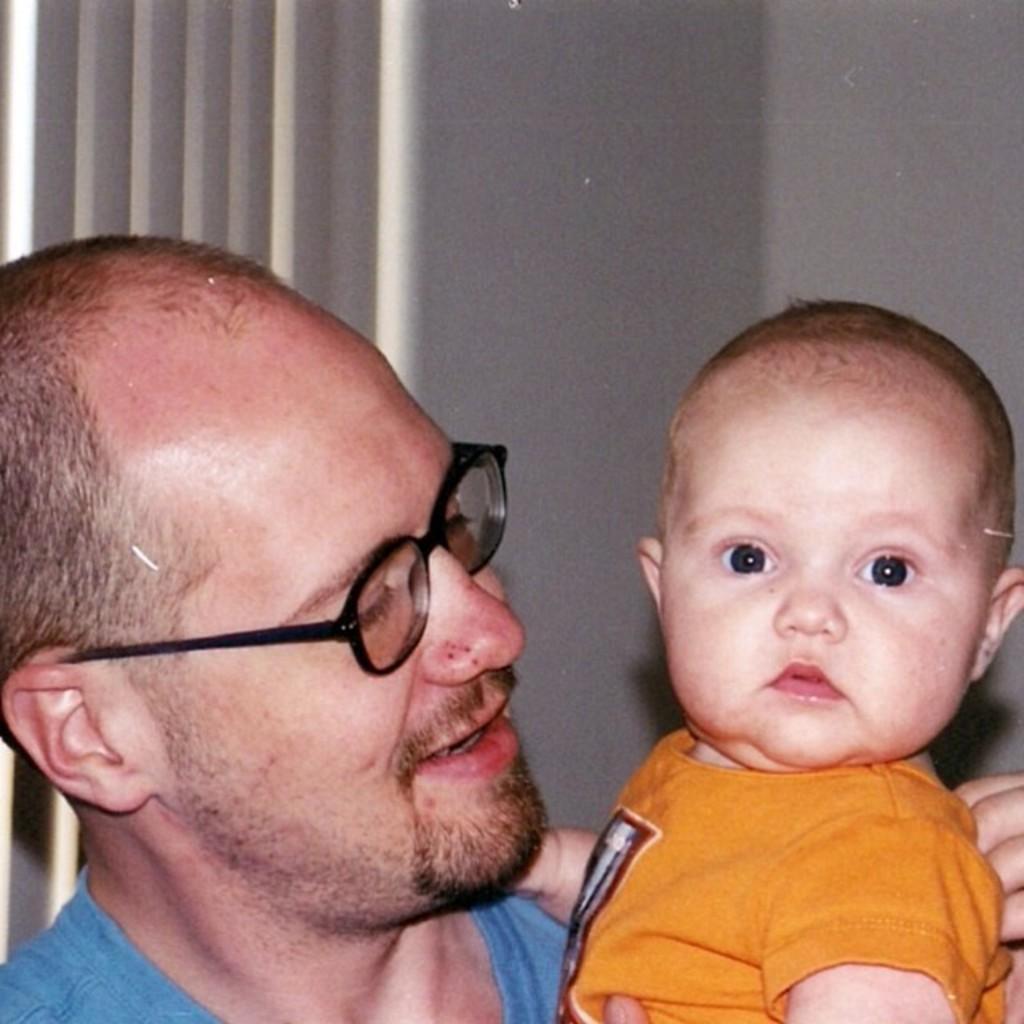In one or two sentences, can you explain what this image depicts? In this image in front there are two persons. Behind them there is a wall. 